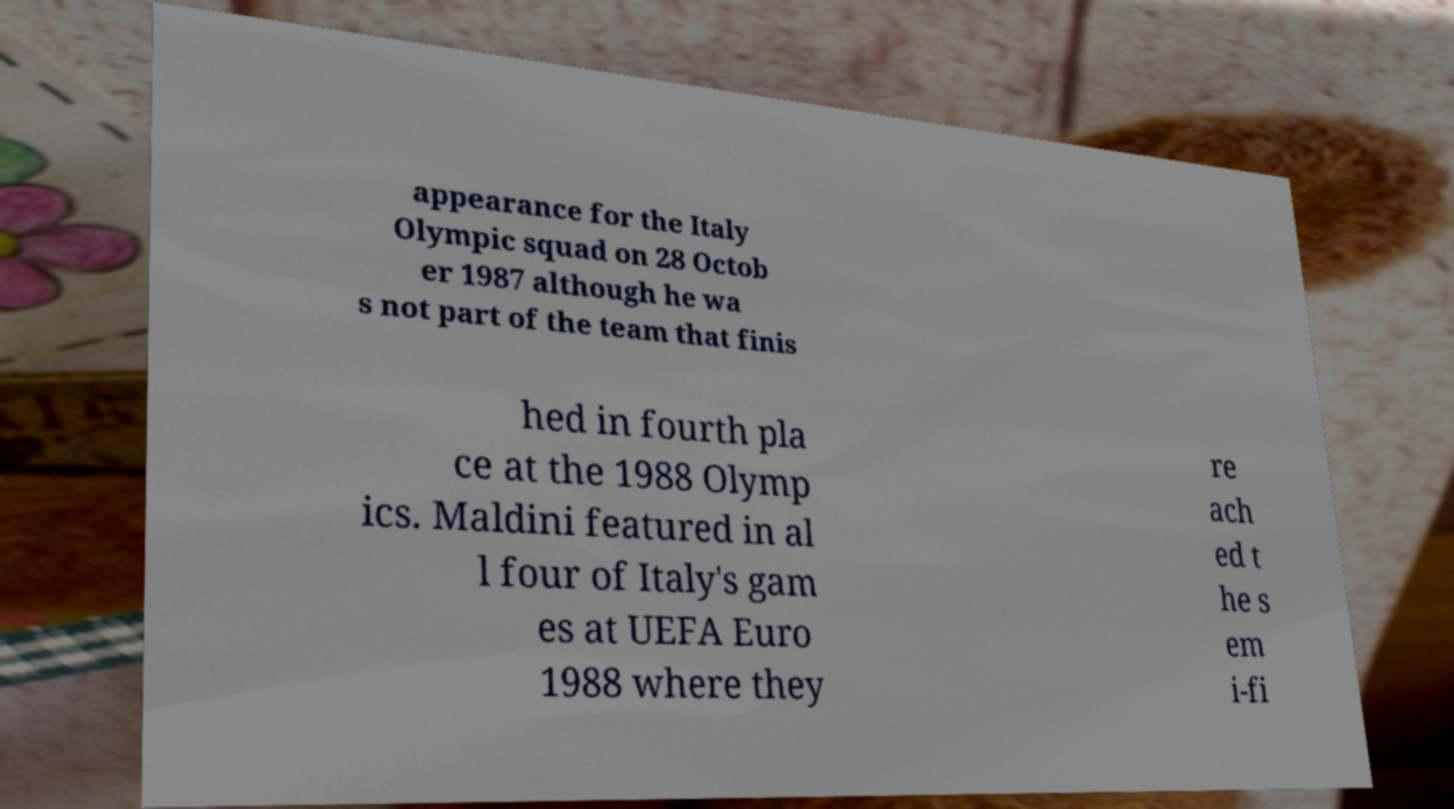Could you extract and type out the text from this image? appearance for the Italy Olympic squad on 28 Octob er 1987 although he wa s not part of the team that finis hed in fourth pla ce at the 1988 Olymp ics. Maldini featured in al l four of Italy's gam es at UEFA Euro 1988 where they re ach ed t he s em i-fi 